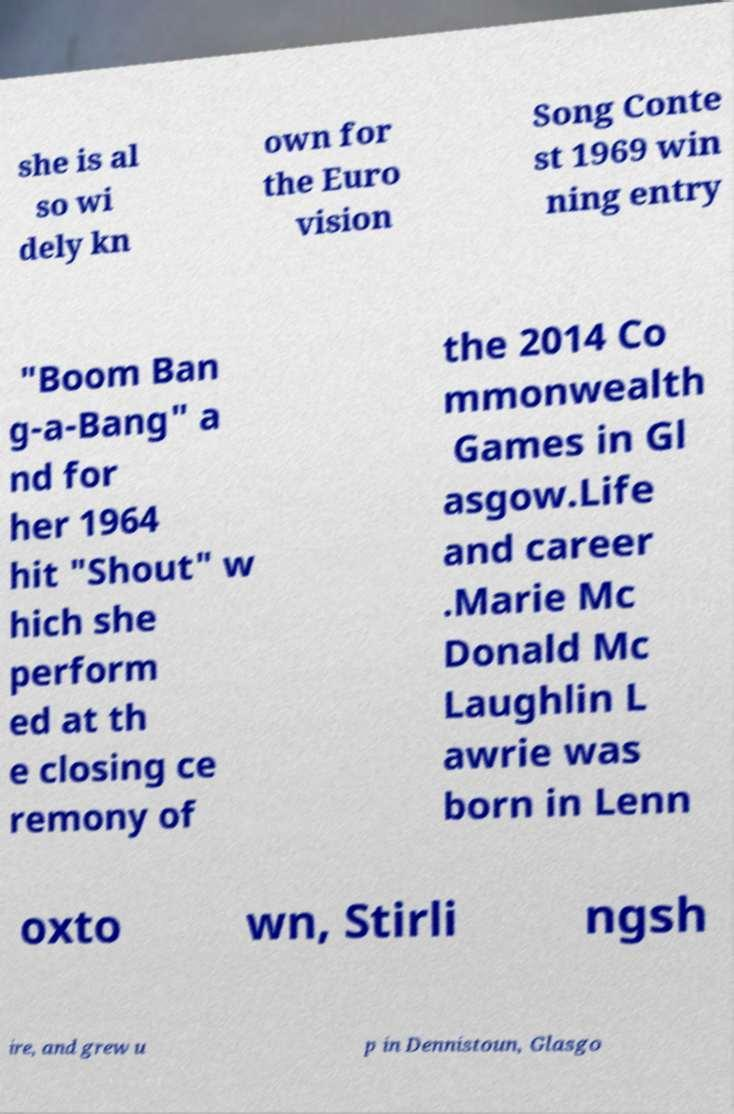Could you extract and type out the text from this image? she is al so wi dely kn own for the Euro vision Song Conte st 1969 win ning entry "Boom Ban g-a-Bang" a nd for her 1964 hit "Shout" w hich she perform ed at th e closing ce remony of the 2014 Co mmonwealth Games in Gl asgow.Life and career .Marie Mc Donald Mc Laughlin L awrie was born in Lenn oxto wn, Stirli ngsh ire, and grew u p in Dennistoun, Glasgo 